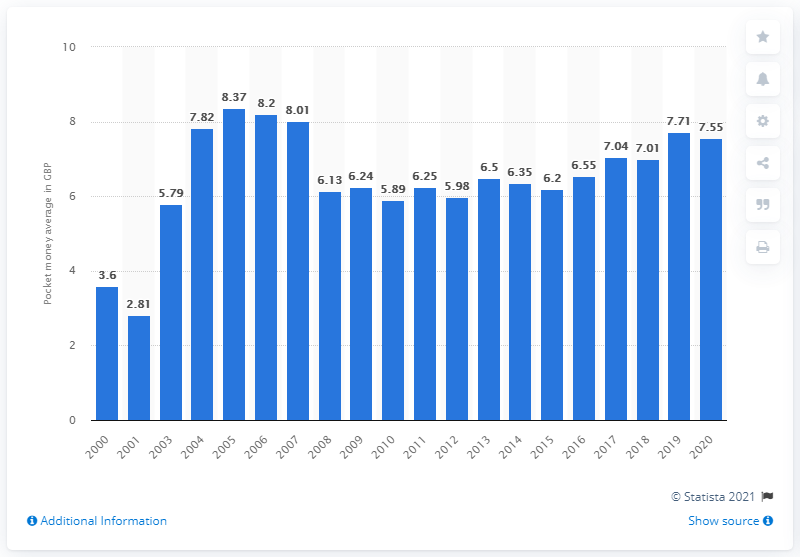List a handful of essential elements in this visual. In 2020, the average amount of British pounds earned per week was 7.55. 